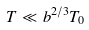<formula> <loc_0><loc_0><loc_500><loc_500>T \ll b ^ { 2 / 3 } T _ { 0 }</formula> 